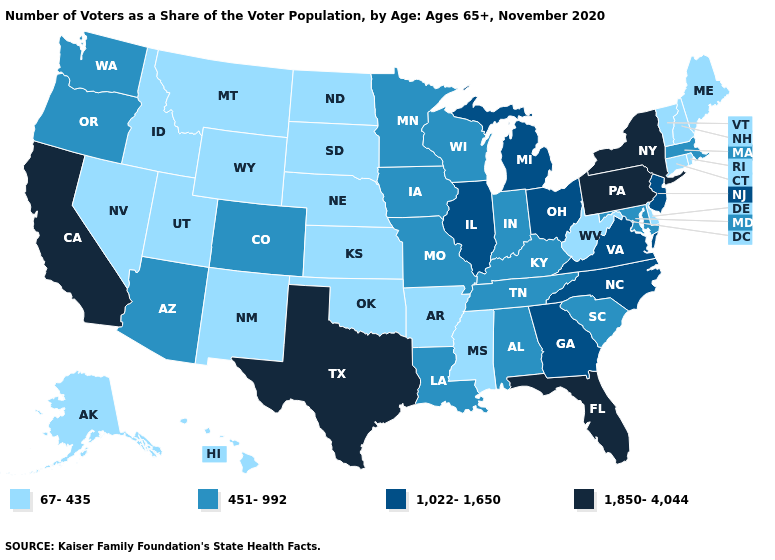Name the states that have a value in the range 451-992?
Write a very short answer. Alabama, Arizona, Colorado, Indiana, Iowa, Kentucky, Louisiana, Maryland, Massachusetts, Minnesota, Missouri, Oregon, South Carolina, Tennessee, Washington, Wisconsin. How many symbols are there in the legend?
Write a very short answer. 4. Name the states that have a value in the range 451-992?
Concise answer only. Alabama, Arizona, Colorado, Indiana, Iowa, Kentucky, Louisiana, Maryland, Massachusetts, Minnesota, Missouri, Oregon, South Carolina, Tennessee, Washington, Wisconsin. Does Massachusetts have the lowest value in the Northeast?
Write a very short answer. No. Name the states that have a value in the range 451-992?
Keep it brief. Alabama, Arizona, Colorado, Indiana, Iowa, Kentucky, Louisiana, Maryland, Massachusetts, Minnesota, Missouri, Oregon, South Carolina, Tennessee, Washington, Wisconsin. What is the value of Florida?
Write a very short answer. 1,850-4,044. What is the value of Missouri?
Quick response, please. 451-992. Name the states that have a value in the range 451-992?
Concise answer only. Alabama, Arizona, Colorado, Indiana, Iowa, Kentucky, Louisiana, Maryland, Massachusetts, Minnesota, Missouri, Oregon, South Carolina, Tennessee, Washington, Wisconsin. What is the value of Iowa?
Short answer required. 451-992. Does North Carolina have the same value as Pennsylvania?
Short answer required. No. Name the states that have a value in the range 1,022-1,650?
Quick response, please. Georgia, Illinois, Michigan, New Jersey, North Carolina, Ohio, Virginia. What is the value of Maryland?
Write a very short answer. 451-992. Which states have the highest value in the USA?
Answer briefly. California, Florida, New York, Pennsylvania, Texas. How many symbols are there in the legend?
Give a very brief answer. 4. What is the lowest value in the USA?
Quick response, please. 67-435. 